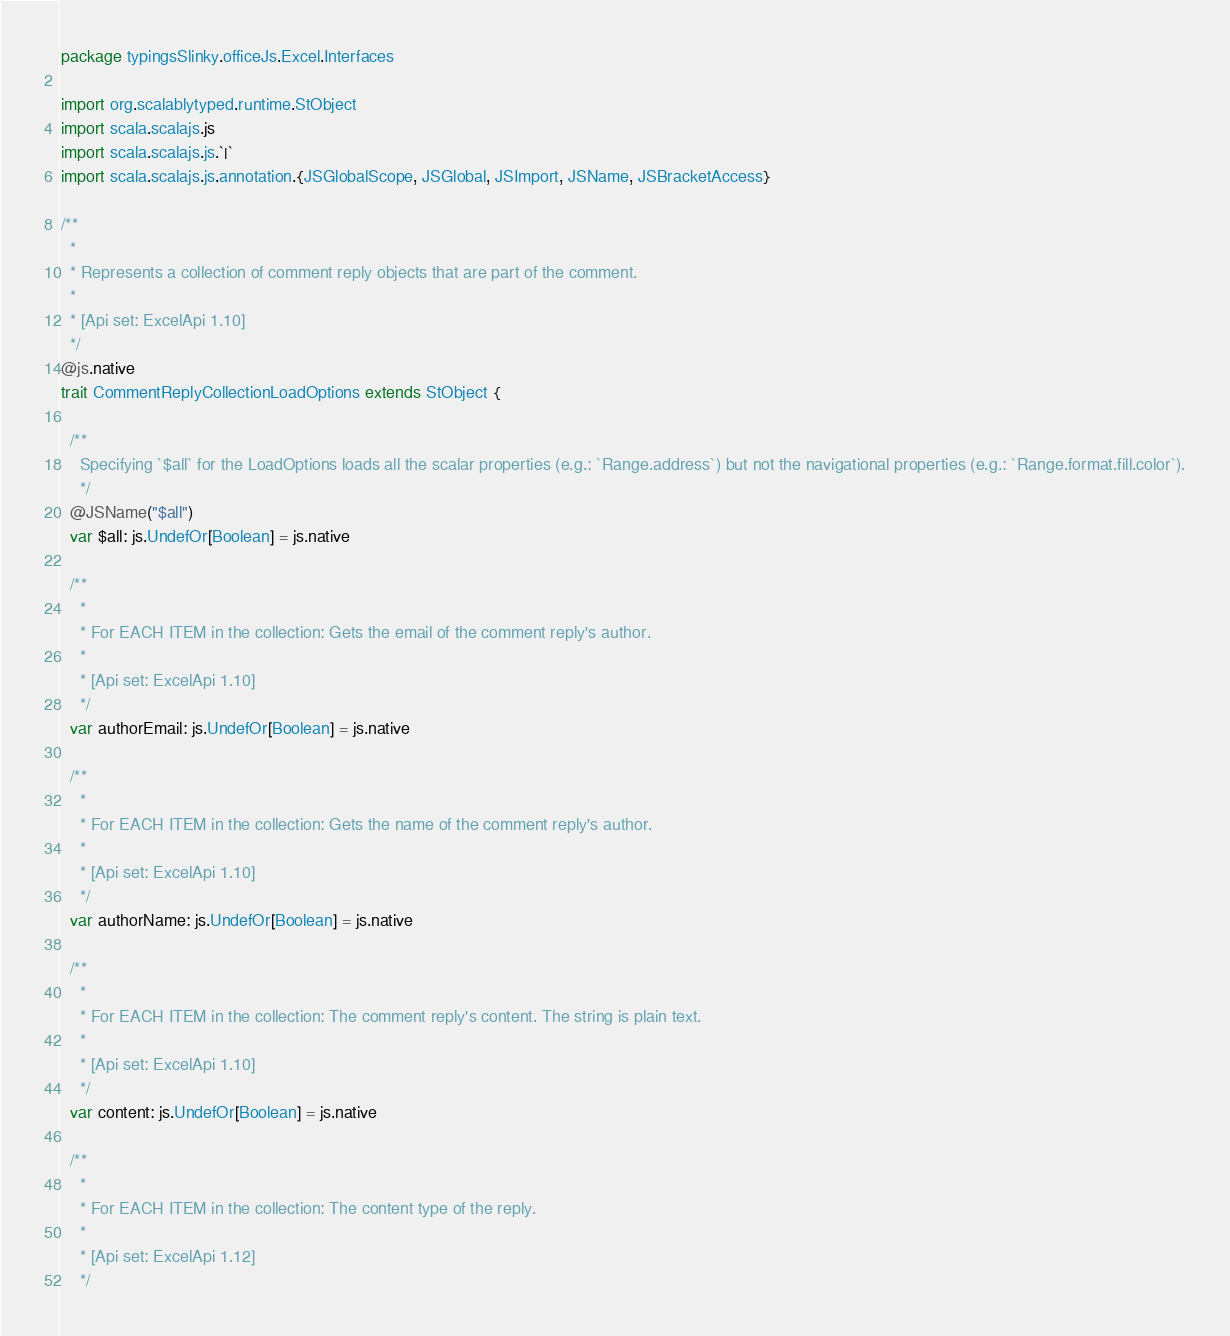Convert code to text. <code><loc_0><loc_0><loc_500><loc_500><_Scala_>package typingsSlinky.officeJs.Excel.Interfaces

import org.scalablytyped.runtime.StObject
import scala.scalajs.js
import scala.scalajs.js.`|`
import scala.scalajs.js.annotation.{JSGlobalScope, JSGlobal, JSImport, JSName, JSBracketAccess}

/**
  *
  * Represents a collection of comment reply objects that are part of the comment.
  *
  * [Api set: ExcelApi 1.10]
  */
@js.native
trait CommentReplyCollectionLoadOptions extends StObject {
  
  /**
    Specifying `$all` for the LoadOptions loads all the scalar properties (e.g.: `Range.address`) but not the navigational properties (e.g.: `Range.format.fill.color`).
    */
  @JSName("$all")
  var $all: js.UndefOr[Boolean] = js.native
  
  /**
    *
    * For EACH ITEM in the collection: Gets the email of the comment reply's author.
    *
    * [Api set: ExcelApi 1.10]
    */
  var authorEmail: js.UndefOr[Boolean] = js.native
  
  /**
    *
    * For EACH ITEM in the collection: Gets the name of the comment reply's author.
    *
    * [Api set: ExcelApi 1.10]
    */
  var authorName: js.UndefOr[Boolean] = js.native
  
  /**
    *
    * For EACH ITEM in the collection: The comment reply's content. The string is plain text.
    *
    * [Api set: ExcelApi 1.10]
    */
  var content: js.UndefOr[Boolean] = js.native
  
  /**
    *
    * For EACH ITEM in the collection: The content type of the reply.
    *
    * [Api set: ExcelApi 1.12]
    */</code> 